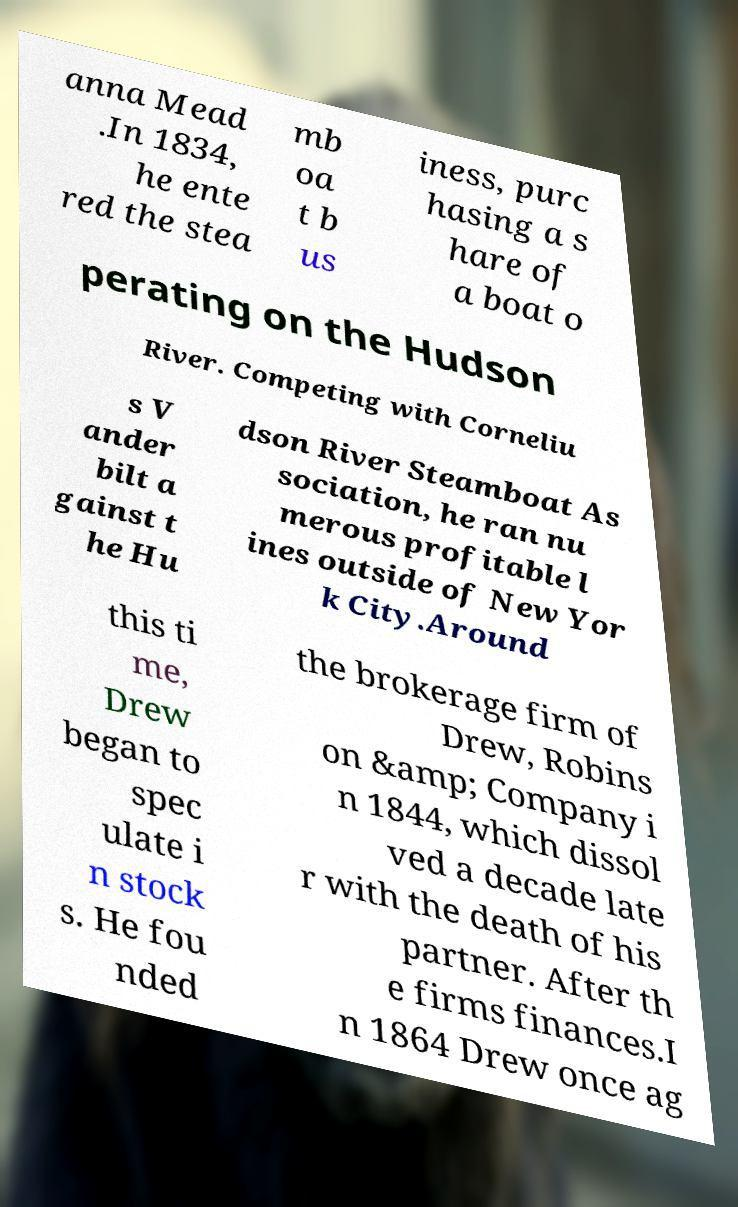Could you extract and type out the text from this image? anna Mead .In 1834, he ente red the stea mb oa t b us iness, purc hasing a s hare of a boat o perating on the Hudson River. Competing with Corneliu s V ander bilt a gainst t he Hu dson River Steamboat As sociation, he ran nu merous profitable l ines outside of New Yor k City.Around this ti me, Drew began to spec ulate i n stock s. He fou nded the brokerage firm of Drew, Robins on &amp; Company i n 1844, which dissol ved a decade late r with the death of his partner. After th e firms finances.I n 1864 Drew once ag 